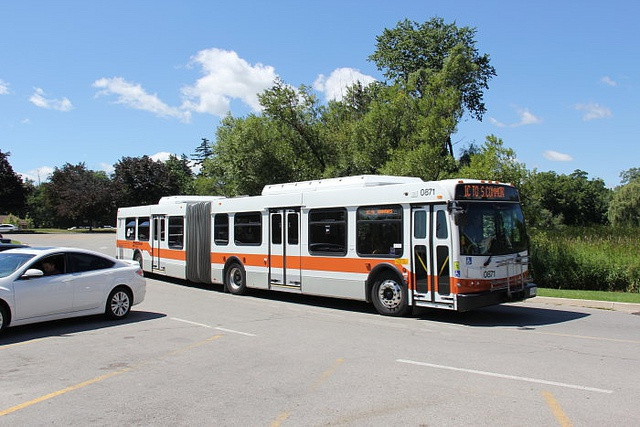Describe the objects in this image and their specific colors. I can see bus in lightblue, black, lightgray, gray, and darkgray tones, car in lightblue, darkgray, black, lightgray, and gray tones, and car in lightblue, black, darkgray, gray, and lightgray tones in this image. 